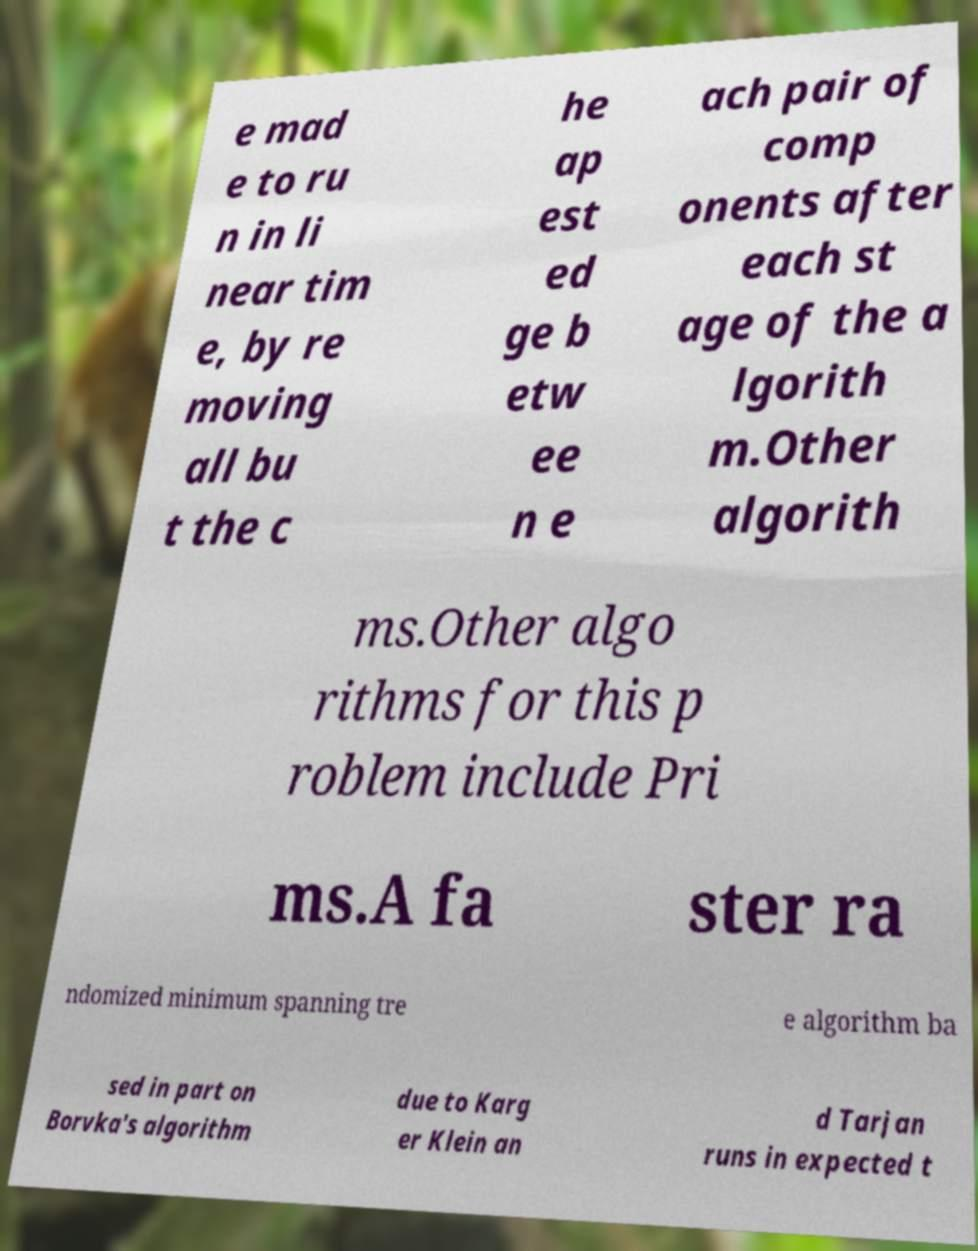Can you accurately transcribe the text from the provided image for me? e mad e to ru n in li near tim e, by re moving all bu t the c he ap est ed ge b etw ee n e ach pair of comp onents after each st age of the a lgorith m.Other algorith ms.Other algo rithms for this p roblem include Pri ms.A fa ster ra ndomized minimum spanning tre e algorithm ba sed in part on Borvka's algorithm due to Karg er Klein an d Tarjan runs in expected t 